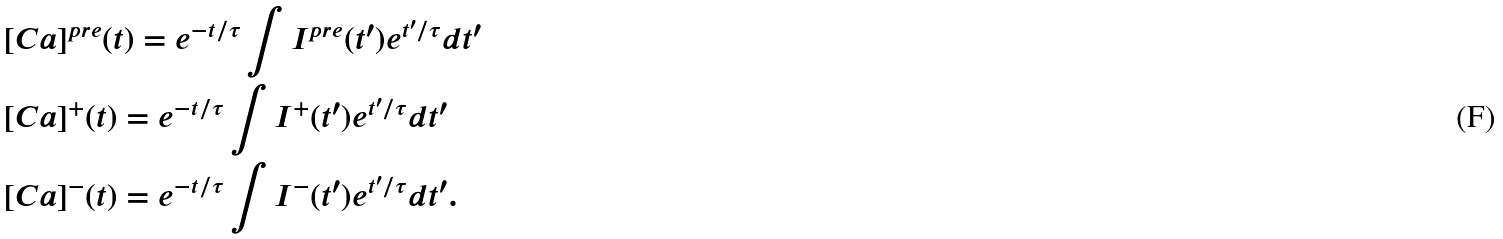Convert formula to latex. <formula><loc_0><loc_0><loc_500><loc_500>& [ C a ] ^ { p r e } ( t ) = e ^ { - t / \tau } \int I ^ { p r e } ( t ^ { \prime } ) e ^ { t ^ { \prime } / \tau } d t ^ { \prime } \\ & [ C a ] ^ { + } ( t ) = e ^ { - t / \tau } \int I ^ { + } ( t ^ { \prime } ) e ^ { t ^ { \prime } / \tau } d t ^ { \prime } \\ & [ C a ] ^ { - } ( t ) = e ^ { - t / \tau } \int I ^ { - } ( t ^ { \prime } ) e ^ { t ^ { \prime } / \tau } d t ^ { \prime } .</formula> 